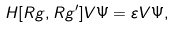<formula> <loc_0><loc_0><loc_500><loc_500>H [ R g , R g ^ { \prime } ] V \Psi = \varepsilon V \Psi ,</formula> 